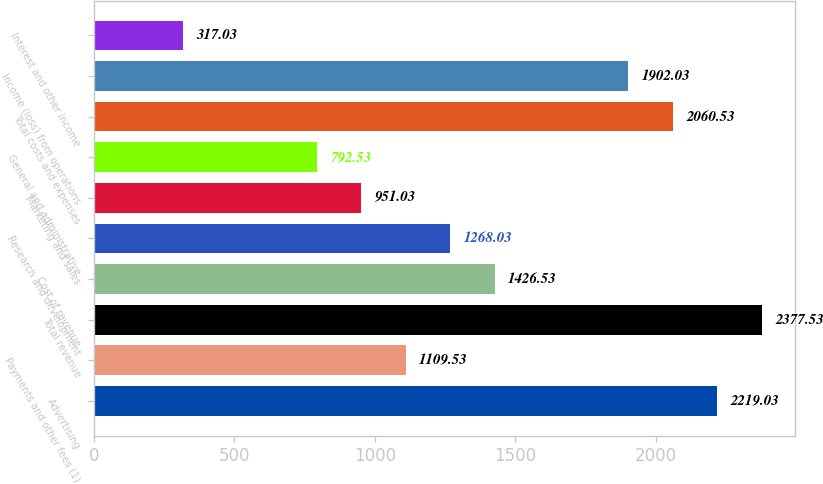Convert chart. <chart><loc_0><loc_0><loc_500><loc_500><bar_chart><fcel>Advertising<fcel>Payments and other fees (1)<fcel>Total revenue<fcel>Cost of revenue<fcel>Research and development<fcel>Marketing and sales<fcel>General and administrative<fcel>Total costs and expenses<fcel>Income (loss) from operations<fcel>Interest and other income<nl><fcel>2219.03<fcel>1109.53<fcel>2377.53<fcel>1426.53<fcel>1268.03<fcel>951.03<fcel>792.53<fcel>2060.53<fcel>1902.03<fcel>317.03<nl></chart> 